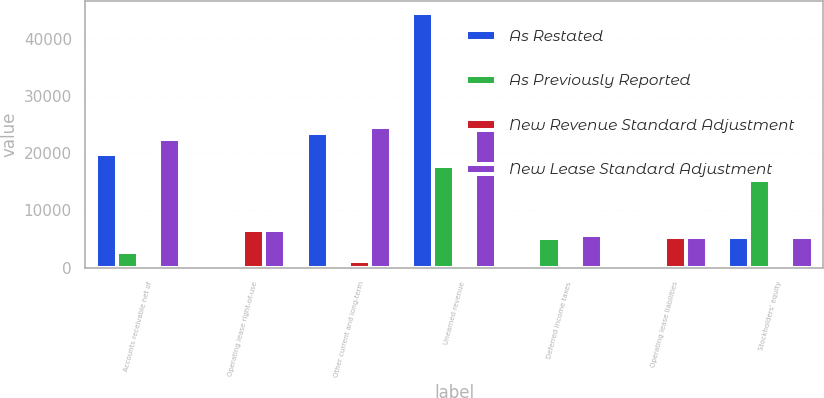<chart> <loc_0><loc_0><loc_500><loc_500><stacked_bar_chart><ecel><fcel>Accounts receivable net of<fcel>Operating lease right-of-use<fcel>Other current and long-term<fcel>Unearned revenue<fcel>Deferred income taxes<fcel>Operating lease liabilities<fcel>Stockholders' equity<nl><fcel>As Restated<fcel>19792<fcel>0<fcel>23464<fcel>44479<fcel>531<fcel>0<fcel>5287.5<nl><fcel>As Previously Reported<fcel>2639<fcel>0<fcel>26<fcel>17823<fcel>5203<fcel>0<fcel>15317<nl><fcel>New Revenue Standard Adjustment<fcel>0<fcel>6555<fcel>1183<fcel>0<fcel>0<fcel>5372<fcel>0<nl><fcel>New Lease Standard Adjustment<fcel>22431<fcel>6555<fcel>24621<fcel>26656<fcel>5734<fcel>5372<fcel>5287.5<nl></chart> 